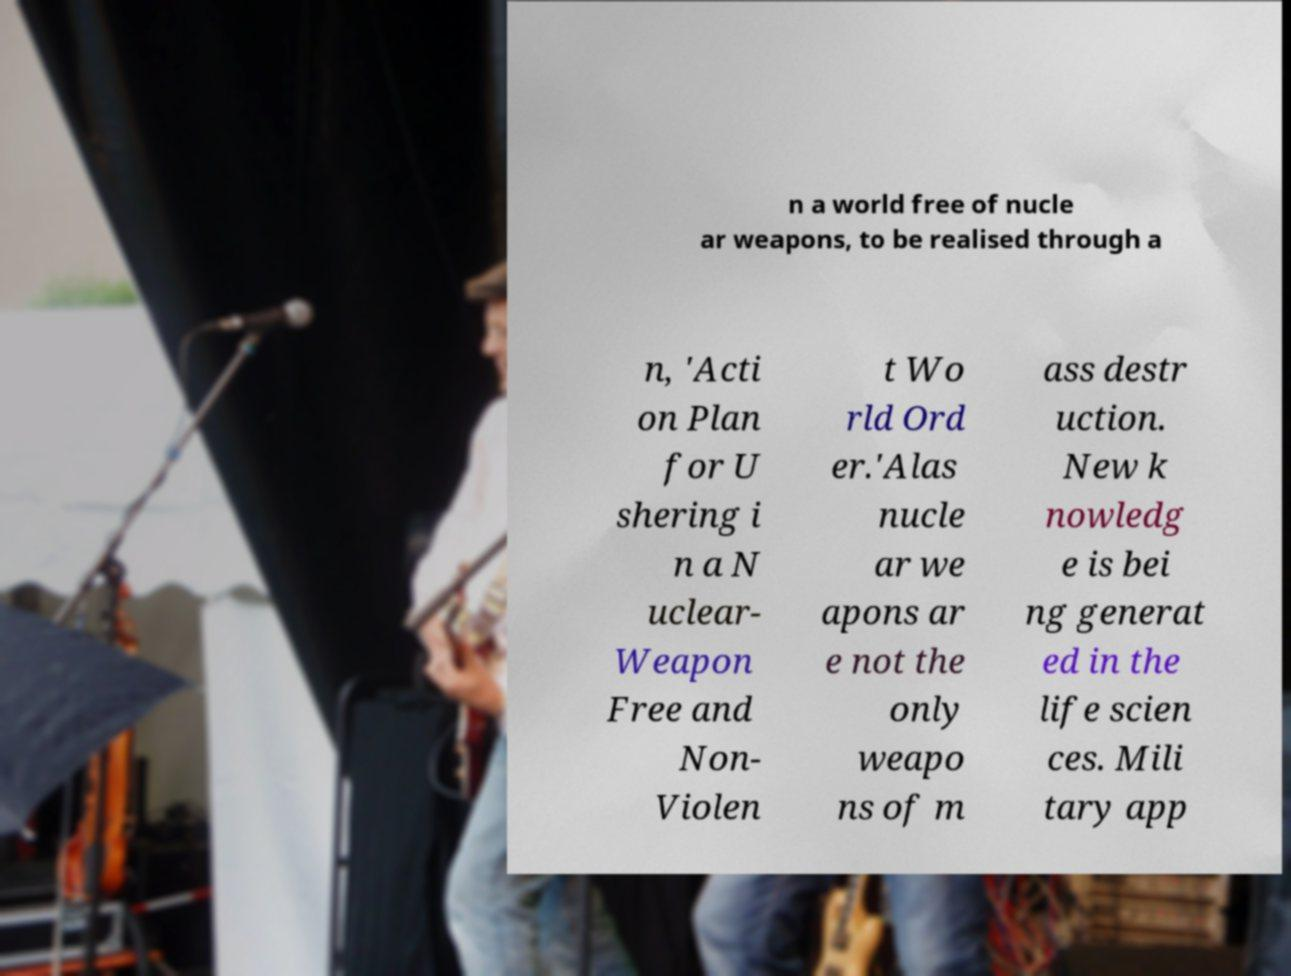There's text embedded in this image that I need extracted. Can you transcribe it verbatim? n a world free of nucle ar weapons, to be realised through a n, 'Acti on Plan for U shering i n a N uclear- Weapon Free and Non- Violen t Wo rld Ord er.'Alas nucle ar we apons ar e not the only weapo ns of m ass destr uction. New k nowledg e is bei ng generat ed in the life scien ces. Mili tary app 